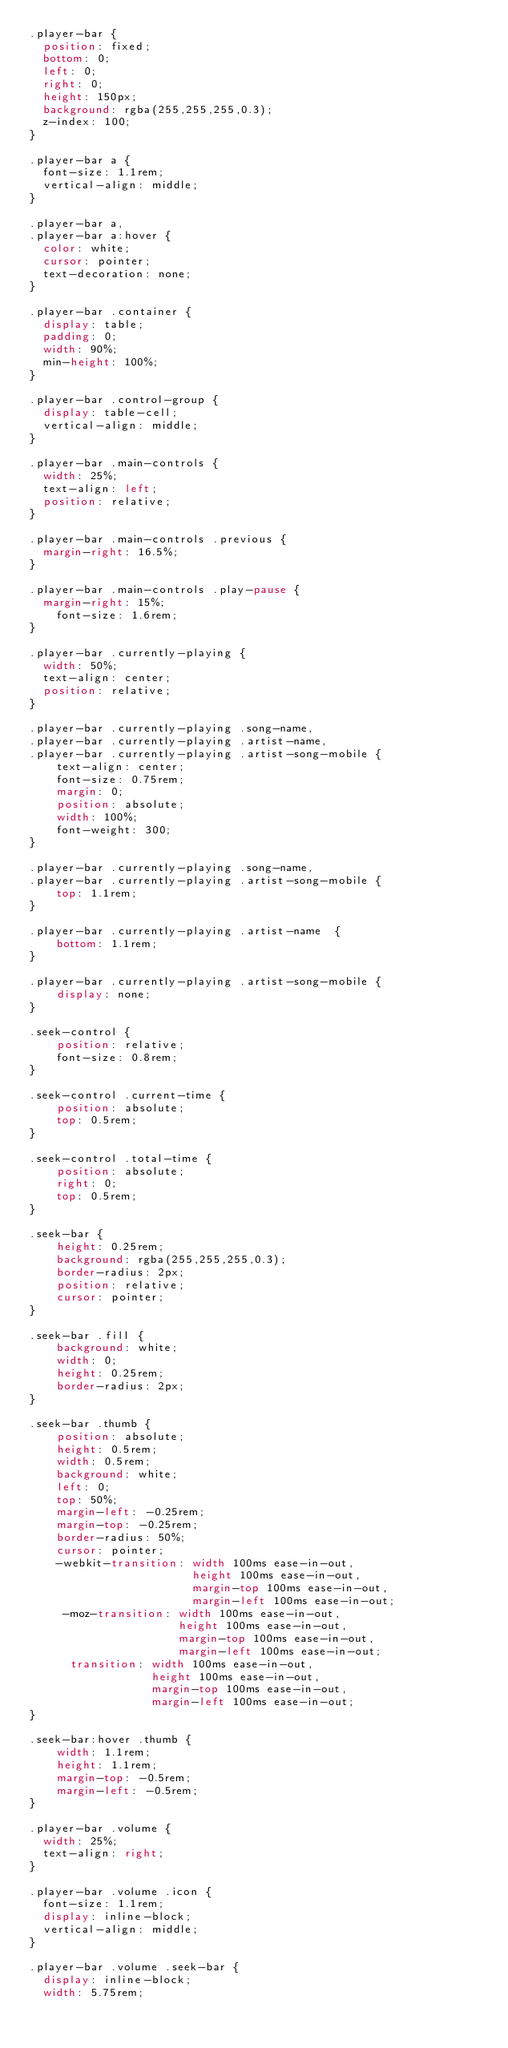Convert code to text. <code><loc_0><loc_0><loc_500><loc_500><_CSS_>.player-bar {
  position: fixed;
  bottom: 0;
  left: 0;
  right: 0;
  height: 150px;
  background: rgba(255,255,255,0.3);
  z-index: 100;
}

.player-bar a {
  font-size: 1.1rem;
  vertical-align: middle;
}

.player-bar a,
.player-bar a:hover {
  color: white;
  cursor: pointer;
  text-decoration: none;
}

.player-bar .container {
  display: table;
  padding: 0;
  width: 90%;
  min-height: 100%;
}

.player-bar .control-group {
  display: table-cell;
  vertical-align: middle;
}

.player-bar .main-controls {
  width: 25%;
  text-align: left;
  position: relative;
}

.player-bar .main-controls .previous {
  margin-right: 16.5%;
}

.player-bar .main-controls .play-pause {
  margin-right: 15%;
    font-size: 1.6rem;
}

.player-bar .currently-playing {
  width: 50%;
  text-align: center;
  position: relative;
}

.player-bar .currently-playing .song-name,
.player-bar .currently-playing .artist-name,
.player-bar .currently-playing .artist-song-mobile {
    text-align: center;
    font-size: 0.75rem;
    margin: 0;
    position: absolute;
    width: 100%;
    font-weight: 300;
}

.player-bar .currently-playing .song-name,
.player-bar .currently-playing .artist-song-mobile {
    top: 1.1rem;
}

.player-bar .currently-playing .artist-name  {
    bottom: 1.1rem;
}

.player-bar .currently-playing .artist-song-mobile {
    display: none;
}

.seek-control {
    position: relative;
    font-size: 0.8rem;
}

.seek-control .current-time {
    position: absolute;
    top: 0.5rem;
}

.seek-control .total-time {
    position: absolute;
    right: 0;
    top: 0.5rem;
}

.seek-bar {
    height: 0.25rem;
    background: rgba(255,255,255,0.3);
    border-radius: 2px;
    position: relative;
    cursor: pointer;
}

.seek-bar .fill {
    background: white;
    width: 0;
    height: 0.25rem;
    border-radius: 2px;
}

.seek-bar .thumb {
    position: absolute;
    height: 0.5rem;
    width: 0.5rem;
    background: white;
    left: 0;
    top: 50%;
    margin-left: -0.25rem;
    margin-top: -0.25rem;
    border-radius: 50%;
    cursor: pointer;
    -webkit-transition: width 100ms ease-in-out,
                        height 100ms ease-in-out,
                        margin-top 100ms ease-in-out,
                        margin-left 100ms ease-in-out;
     -moz-transition: width 100ms ease-in-out,
                      height 100ms ease-in-out,
                      margin-top 100ms ease-in-out,
                      margin-left 100ms ease-in-out;
      transition: width 100ms ease-in-out,
                  height 100ms ease-in-out,
                  margin-top 100ms ease-in-out,
                  margin-left 100ms ease-in-out;
}

.seek-bar:hover .thumb {
    width: 1.1rem;
    height: 1.1rem;
    margin-top: -0.5rem;
    margin-left: -0.5rem;
}

.player-bar .volume {
  width: 25%;
  text-align: right;
}

.player-bar .volume .icon {
  font-size: 1.1rem;
  display: inline-block;
  vertical-align: middle;
}

.player-bar .volume .seek-bar {
  display: inline-block;
  width: 5.75rem;</code> 